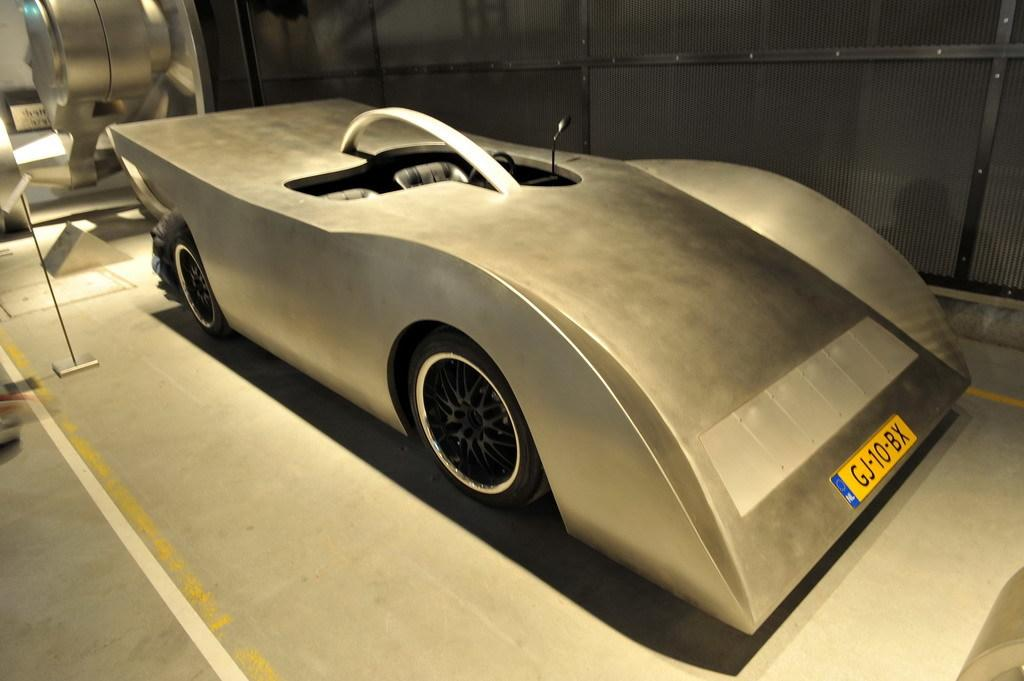What is the main subject of the image? The main subject of the image is a car. What material is the car made of? The car is made of metal. Where is the car located in the image? The car is placed on the floor. What is visible behind the car? There is a wall behind the car. What other metal objects can be seen in the image? There are more metal objects visible in the background. What type of bells can be heard ringing in the image? There are no bells present in the image, and therefore no sound can be heard. 